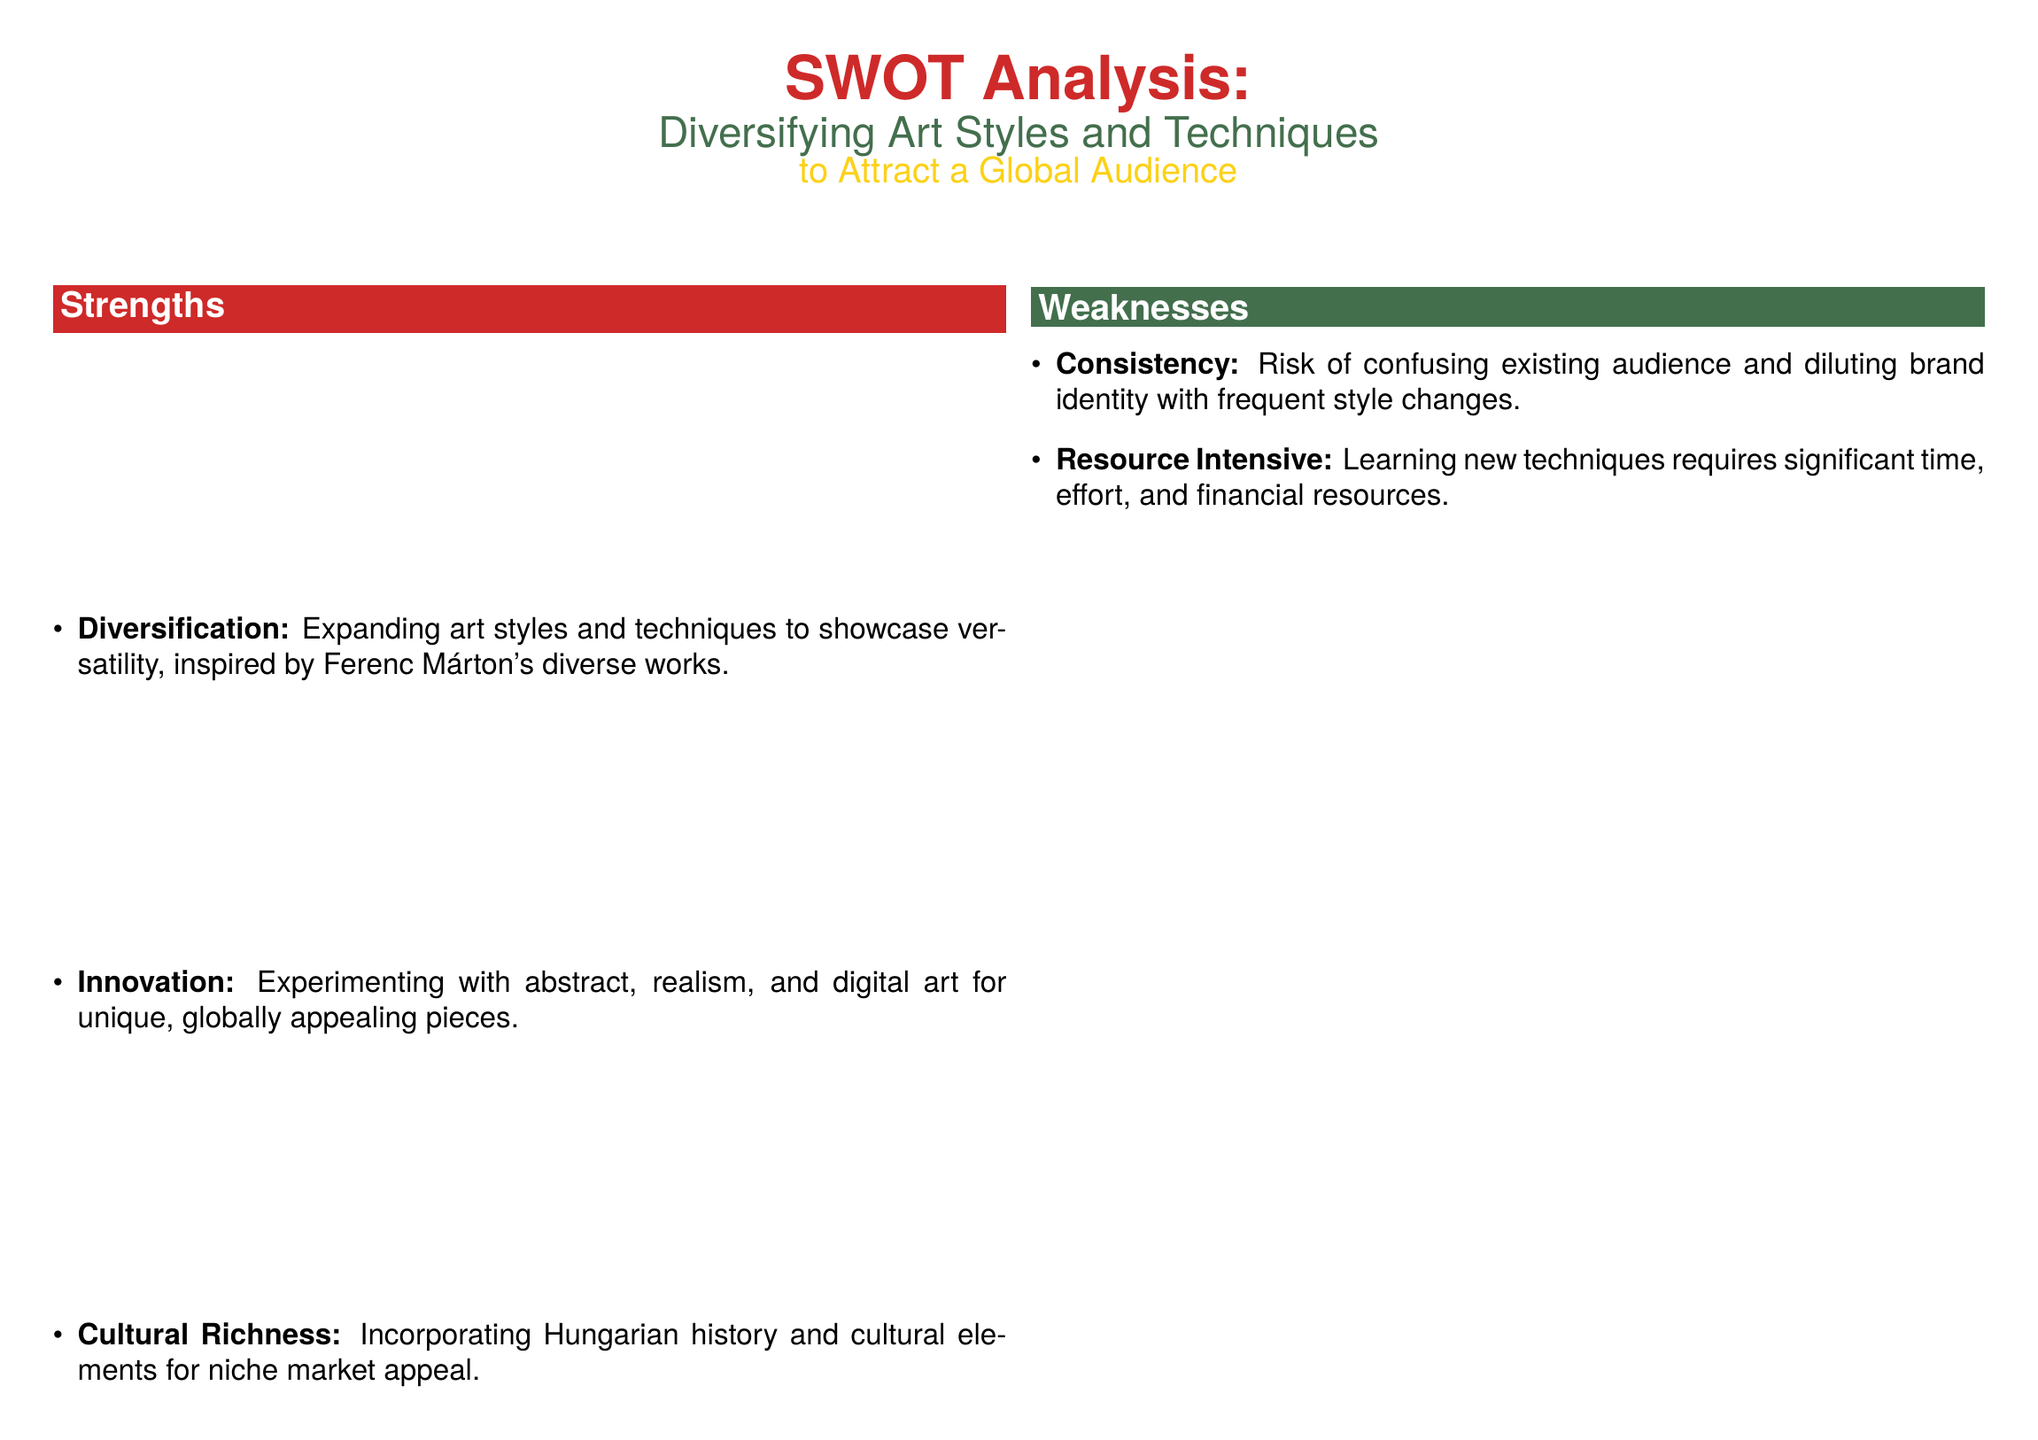What is the main focus of the SWOT analysis? The main focus of the SWOT analysis is to examine the diversifying art styles and techniques to attract a global audience.
Answer: diversifying art styles and techniques to attract a global audience Who is the artist that inspires the document? The document mentions Ferenc Márton as the inspiring artist for diversifying art styles.
Answer: Ferenc Márton What is one of the strengths mentioned in the analysis? The analysis lists "Diversification" as a key strength, emphasizing versatility inspired by Ferenc Márton's works.
Answer: Diversification What opportunity involves online platforms? The document identifies leveraging online platforms like Etsy and Instagram as an opportunity to reach a worldwide audience.
Answer: Global Market What is a weakness related to audience perception? The SWOT analysis points out "Consistency" as a weakness, highlighting the risk of confusing the existing audience.
Answer: Consistency What threat includes cultural aspects? "Cultural Misunderstandings" is mentioned as a threat related to diversifying art styles without proper sensitivity.
Answer: Cultural Misunderstandings What is a potential challenge related to resource allocation? The document states that learning new techniques is "Resource Intensive," requiring significant time and financial resources.
Answer: Resource Intensive Which color is used for the Weaknesses section? The Weaknesses section is presented in the color "hungariangreen."
Answer: hungariangreen 